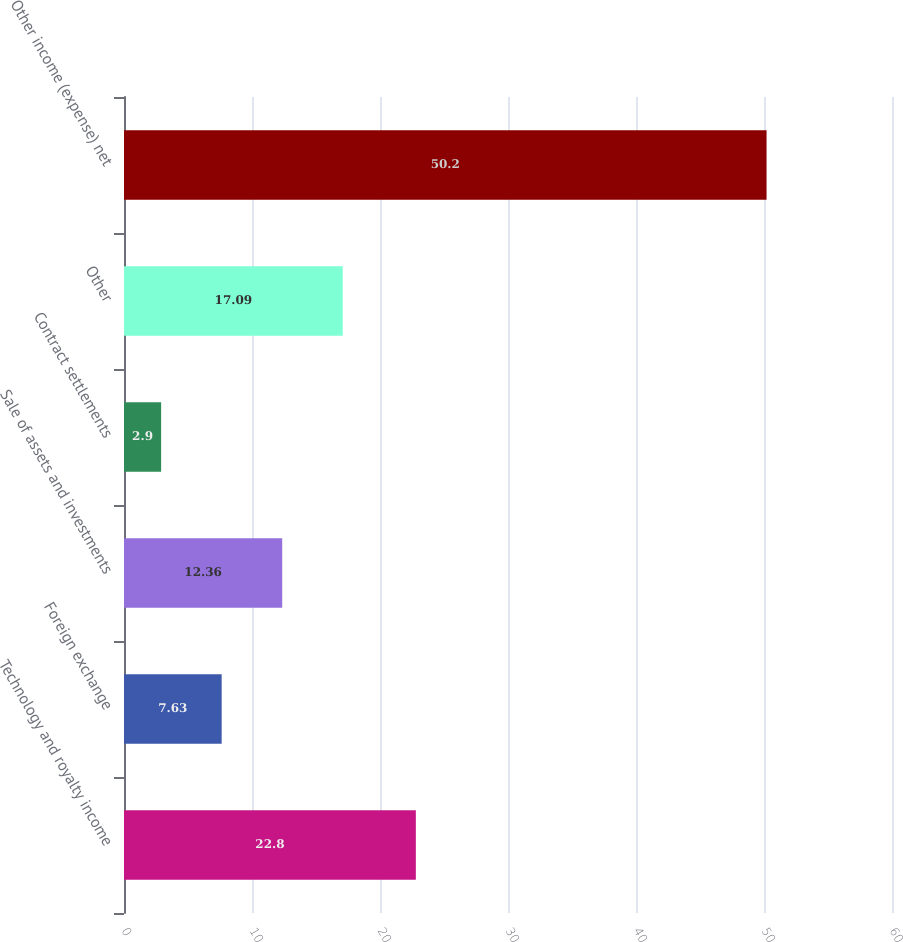<chart> <loc_0><loc_0><loc_500><loc_500><bar_chart><fcel>Technology and royalty income<fcel>Foreign exchange<fcel>Sale of assets and investments<fcel>Contract settlements<fcel>Other<fcel>Other income (expense) net<nl><fcel>22.8<fcel>7.63<fcel>12.36<fcel>2.9<fcel>17.09<fcel>50.2<nl></chart> 